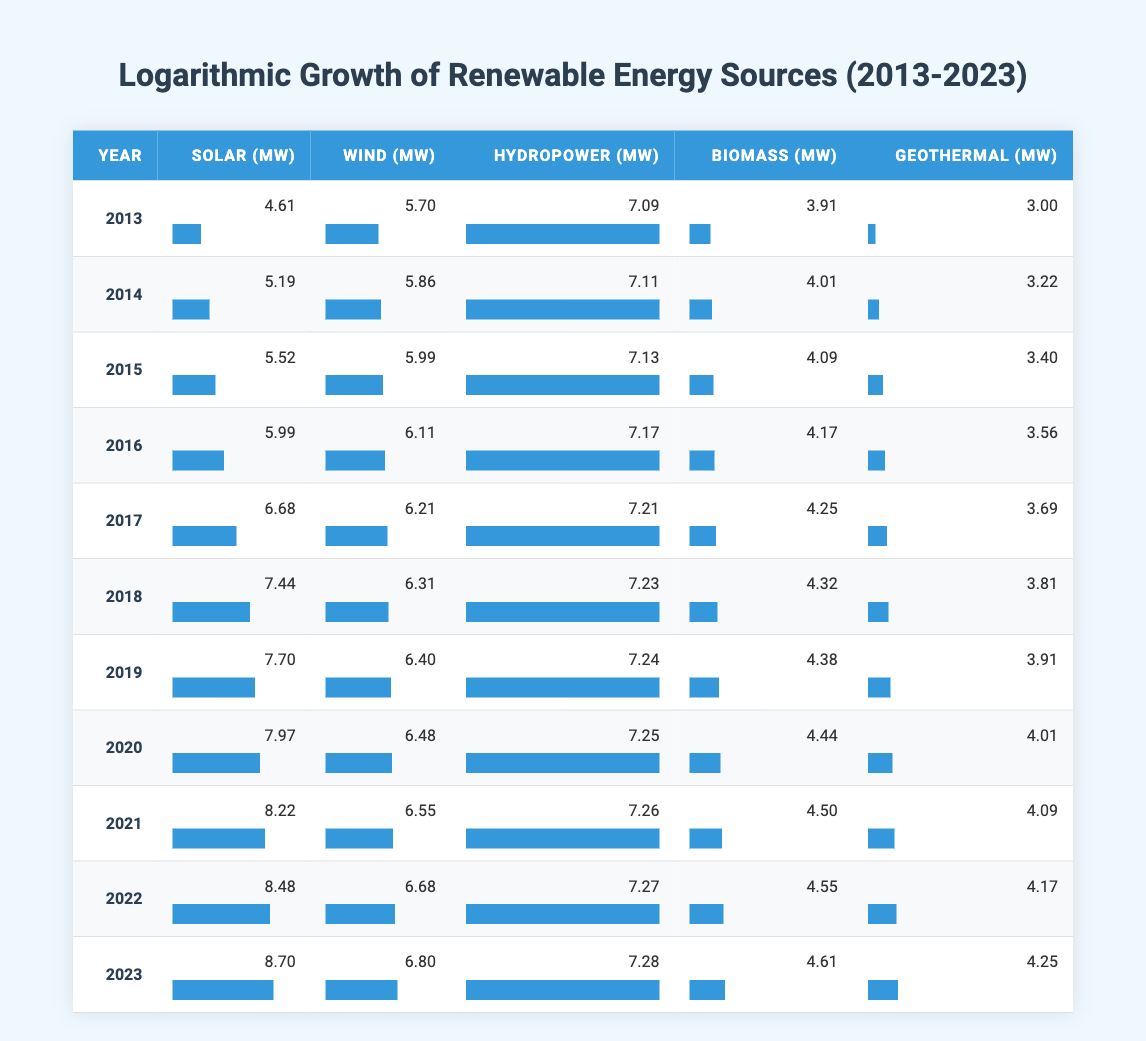What year had the highest solar capacity in megawatts? By looking at the column for solar capacity, the values increase over the years. The highest value is recorded in 2023 at 6000 megawatts.
Answer: 2023 What was the total hydropower capacity from 2013 to 2023? To find the total, you sum the hydropower capacities from each year: 1200 + 1225 + 1250 + 1300 + 1350 + 1375 + 1400 + 1410 + 1425 + 1430 + 1450 = 14145 megawatts.
Answer: 14145 Did the wind capacity increase every year from 2013 to 2023? By checking the wind capacity column, it shows a consistent increase each year from 300 megawatts in 2013 to 900 megawatts in 2023, indicating yes, it increased every year.
Answer: Yes What is the average biomass capacity from 2013 to 2023? The total biomass capacities for the years are: 50 + 55 + 60 + 65 + 70 + 75 + 80 + 85 + 90 + 95 + 100 = 855 megawatts. Dividing by 11 gives an average of 77.73 megawatts.
Answer: 77.73 In which year did the geothermal capacity first exceed 60 megawatts? Observing the geothermal capacity column, the capacity exceeds 60 megawatts for the first time in the year 2021, which is the first year it reaches 60 megawatts.
Answer: 2021 Which renewable energy source had the smallest increase in capacity from 2013 to 2023? Comparing the increases, biomass increased from 50 to 100 megawatts (50), geothermal from 20 to 70 megawatts (50), hydropower from 1200 to 1450 megawatts (250), wind from 300 to 900 (600), and solar from 100 to 6000 (5900). Biomass and geothermal both had the smallest increase of 50 megawatts.
Answer: Biomass and Geothermal How much greater was the solar capacity in 2022 compared to 2016? The solar capacities were 4800 megawatts in 2022 and 400 megawatts in 2016. The difference is 4800 - 400 = 4400 megawatts.
Answer: 4400 Was the wind capacity in 2023 more than the combined capacities of biomass and geothermal for that year? The wind capacity in 2023 is 900 megawatts. The combined capacities for biomass and geothermal in 2023 are 100 + 70 = 170 megawatts. Since 900 is greater than 170, the statement is true.
Answer: Yes 